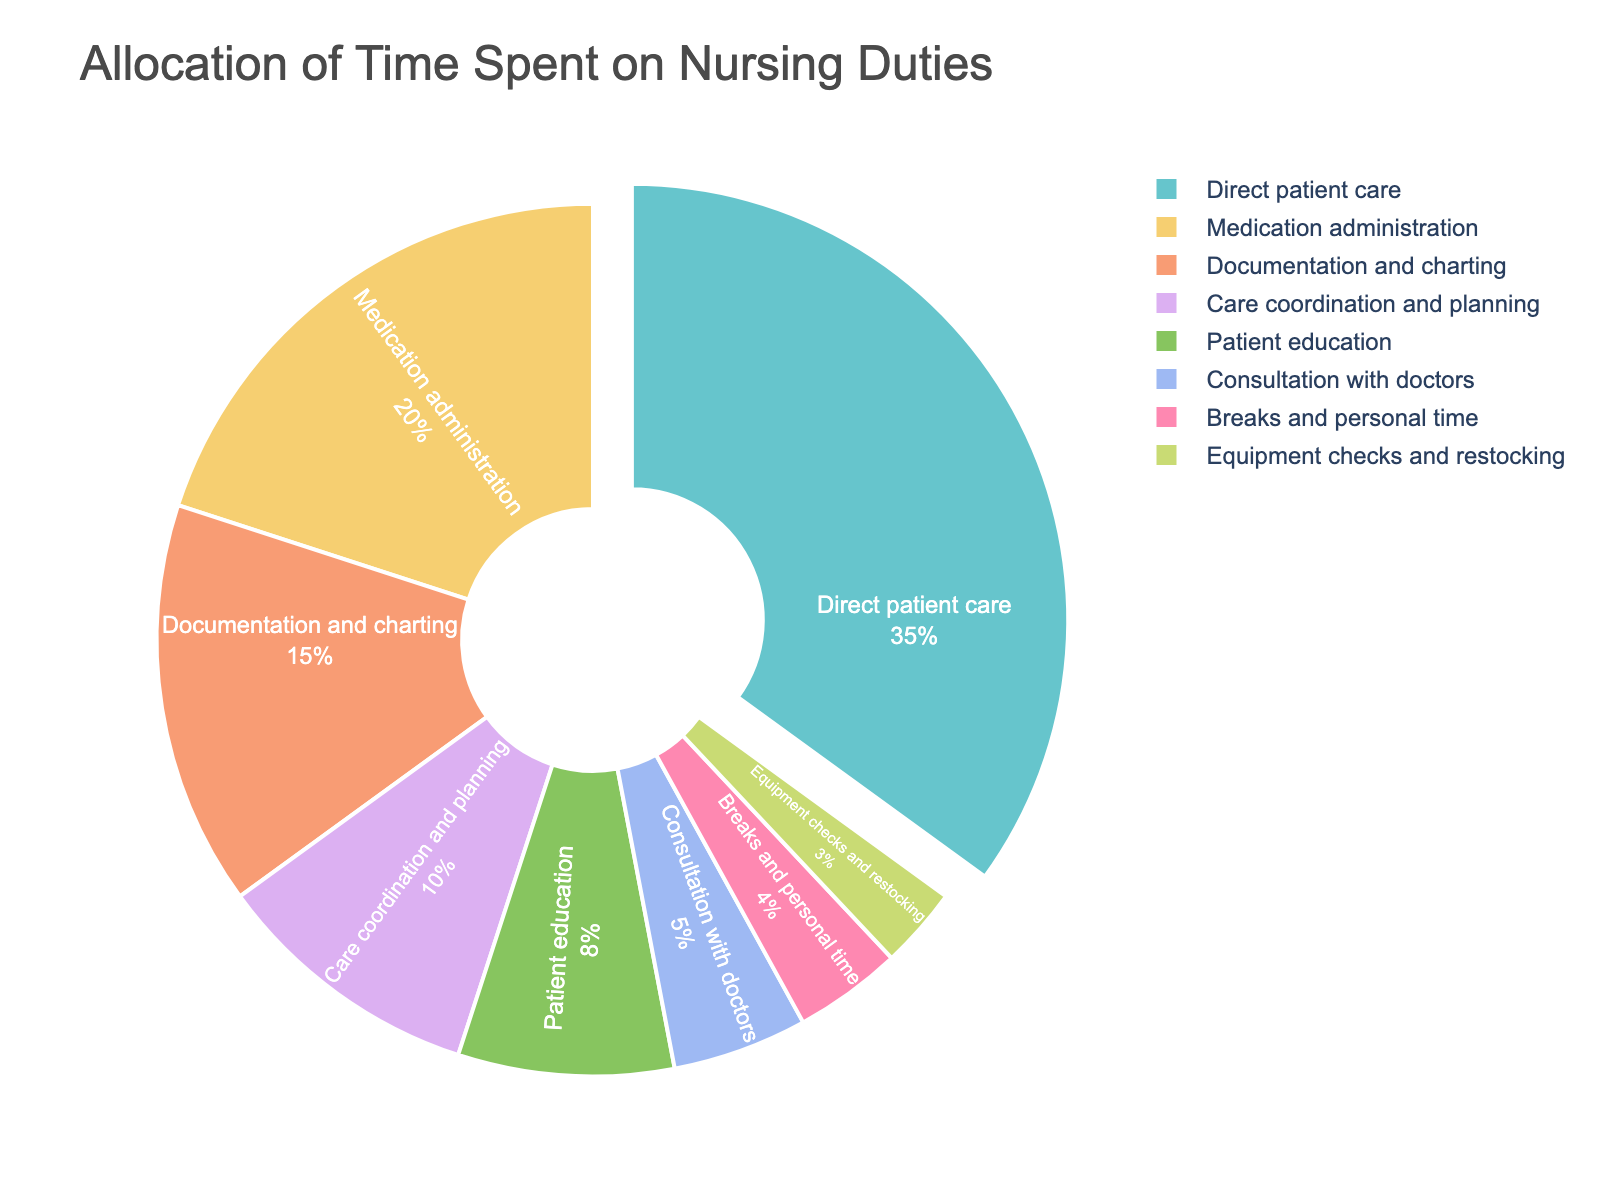What task takes up the largest percentage of time? The pie chart shows that "Direct patient care" occupies the largest section of the chart, which is 35%.
Answer: Direct patient care Which two tasks combined take up the same amount of time as "Direct patient care"? "Medication administration" (20%) and "Documentation and charting" (15%) together sum to 20% + 15% = 35%, equal to "Direct patient care".
Answer: Medication administration and Documentation and charting Which tasks take up less than 5% of the time each? The chart shows that "Consultation with doctors" (5%), "Equipment checks and restocking" (3%), and "Breaks and personal time" (4%) each occupy less than 5%.
Answer: Equipment checks and restocking, and Breaks and personal time How much more time is spent on "Medication administration" compared to "Patient education"? The percentage for "Medication administration" is 20% and for "Patient education" is 8%. The difference is 20% - 8% = 12%.
Answer: 12% more What is the second least time-consuming task? The pie chart reveals that "Equipment checks and restocking" takes 3%, which is the least time-consuming. The next least time-consuming task is "Breaks and personal time" at 4%.
Answer: Breaks and personal time 